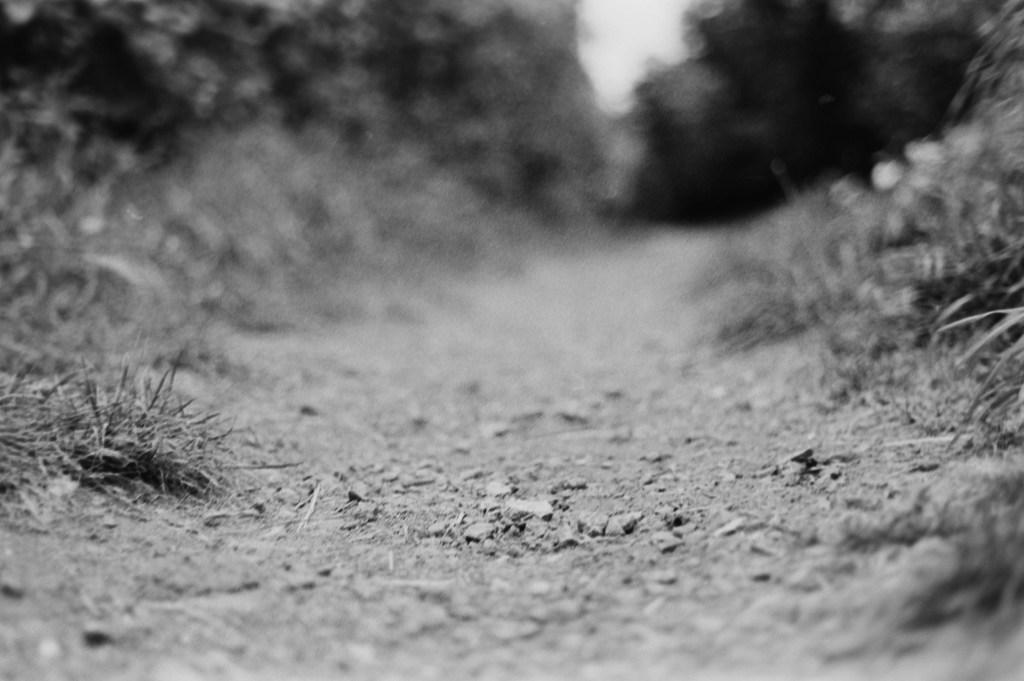Describe this image in one or two sentences. This is the picture of a mud road. On the left and on the right side of the image there are trees. At the top there is sky. At the bottom there are small stones and there is grass. 